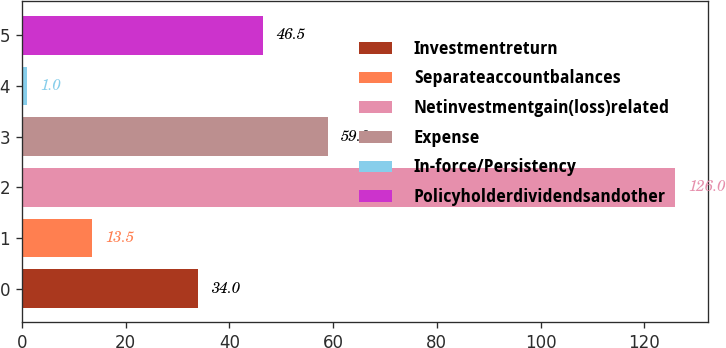Convert chart. <chart><loc_0><loc_0><loc_500><loc_500><bar_chart><fcel>Investmentreturn<fcel>Separateaccountbalances<fcel>Netinvestmentgain(loss)related<fcel>Expense<fcel>In-force/Persistency<fcel>Policyholderdividendsandother<nl><fcel>34<fcel>13.5<fcel>126<fcel>59<fcel>1<fcel>46.5<nl></chart> 